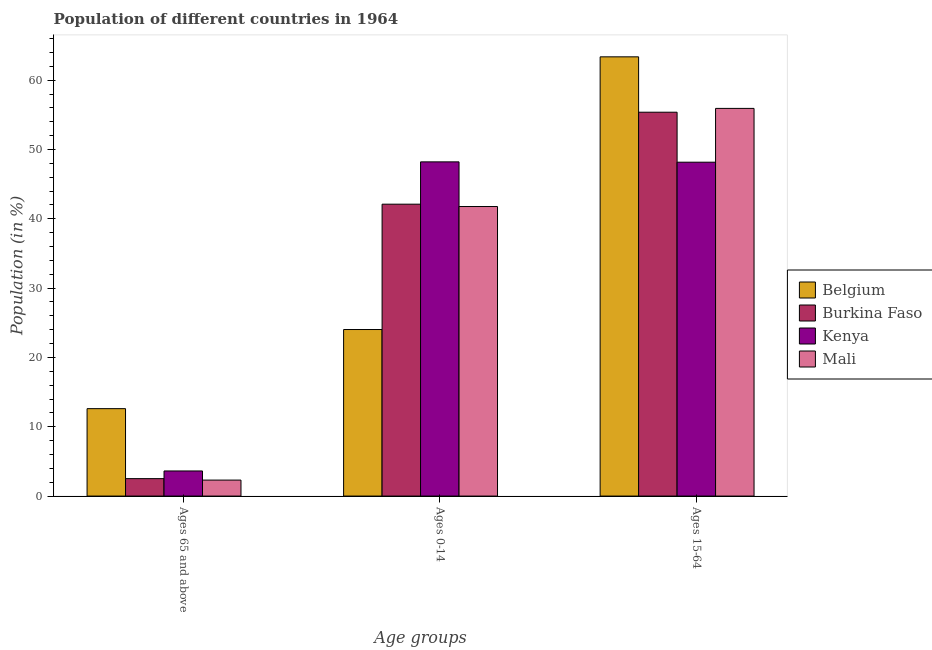How many different coloured bars are there?
Give a very brief answer. 4. Are the number of bars per tick equal to the number of legend labels?
Your answer should be very brief. Yes. How many bars are there on the 3rd tick from the left?
Offer a very short reply. 4. What is the label of the 2nd group of bars from the left?
Provide a short and direct response. Ages 0-14. What is the percentage of population within the age-group of 65 and above in Burkina Faso?
Your response must be concise. 2.52. Across all countries, what is the maximum percentage of population within the age-group 0-14?
Your answer should be compact. 48.21. Across all countries, what is the minimum percentage of population within the age-group 15-64?
Offer a very short reply. 48.17. In which country was the percentage of population within the age-group of 65 and above maximum?
Keep it short and to the point. Belgium. What is the total percentage of population within the age-group of 65 and above in the graph?
Your response must be concise. 21.05. What is the difference between the percentage of population within the age-group 0-14 in Belgium and that in Kenya?
Offer a very short reply. -24.19. What is the difference between the percentage of population within the age-group 15-64 in Burkina Faso and the percentage of population within the age-group of 65 and above in Belgium?
Provide a short and direct response. 42.76. What is the average percentage of population within the age-group 15-64 per country?
Your answer should be compact. 55.71. What is the difference between the percentage of population within the age-group 0-14 and percentage of population within the age-group of 65 and above in Mali?
Ensure brevity in your answer.  39.47. In how many countries, is the percentage of population within the age-group 0-14 greater than 54 %?
Offer a very short reply. 0. What is the ratio of the percentage of population within the age-group 0-14 in Burkina Faso to that in Belgium?
Your response must be concise. 1.75. Is the percentage of population within the age-group of 65 and above in Burkina Faso less than that in Mali?
Offer a terse response. No. What is the difference between the highest and the second highest percentage of population within the age-group 0-14?
Your answer should be very brief. 6.1. What is the difference between the highest and the lowest percentage of population within the age-group 0-14?
Your answer should be compact. 24.19. What does the 3rd bar from the left in Ages 15-64 represents?
Your response must be concise. Kenya. What does the 4th bar from the right in Ages 0-14 represents?
Give a very brief answer. Belgium. How many bars are there?
Your answer should be very brief. 12. Are all the bars in the graph horizontal?
Offer a terse response. No. How many countries are there in the graph?
Give a very brief answer. 4. Are the values on the major ticks of Y-axis written in scientific E-notation?
Your answer should be very brief. No. How many legend labels are there?
Your answer should be compact. 4. How are the legend labels stacked?
Keep it short and to the point. Vertical. What is the title of the graph?
Make the answer very short. Population of different countries in 1964. Does "Senegal" appear as one of the legend labels in the graph?
Provide a succinct answer. No. What is the label or title of the X-axis?
Give a very brief answer. Age groups. What is the Population (in %) of Belgium in Ages 65 and above?
Offer a very short reply. 12.61. What is the Population (in %) in Burkina Faso in Ages 65 and above?
Your answer should be very brief. 2.52. What is the Population (in %) of Kenya in Ages 65 and above?
Your answer should be very brief. 3.62. What is the Population (in %) in Mali in Ages 65 and above?
Provide a succinct answer. 2.3. What is the Population (in %) of Belgium in Ages 0-14?
Keep it short and to the point. 24.02. What is the Population (in %) in Burkina Faso in Ages 0-14?
Offer a terse response. 42.11. What is the Population (in %) of Kenya in Ages 0-14?
Offer a terse response. 48.21. What is the Population (in %) of Mali in Ages 0-14?
Your response must be concise. 41.77. What is the Population (in %) in Belgium in Ages 15-64?
Give a very brief answer. 63.36. What is the Population (in %) of Burkina Faso in Ages 15-64?
Offer a terse response. 55.38. What is the Population (in %) of Kenya in Ages 15-64?
Make the answer very short. 48.17. What is the Population (in %) in Mali in Ages 15-64?
Your answer should be compact. 55.93. Across all Age groups, what is the maximum Population (in %) in Belgium?
Ensure brevity in your answer.  63.36. Across all Age groups, what is the maximum Population (in %) in Burkina Faso?
Provide a succinct answer. 55.38. Across all Age groups, what is the maximum Population (in %) of Kenya?
Keep it short and to the point. 48.21. Across all Age groups, what is the maximum Population (in %) of Mali?
Make the answer very short. 55.93. Across all Age groups, what is the minimum Population (in %) in Belgium?
Your answer should be compact. 12.61. Across all Age groups, what is the minimum Population (in %) of Burkina Faso?
Your answer should be compact. 2.52. Across all Age groups, what is the minimum Population (in %) in Kenya?
Your answer should be very brief. 3.62. Across all Age groups, what is the minimum Population (in %) in Mali?
Provide a succinct answer. 2.3. What is the total Population (in %) of Belgium in the graph?
Make the answer very short. 100. What is the total Population (in %) of Burkina Faso in the graph?
Give a very brief answer. 100. What is the total Population (in %) in Kenya in the graph?
Give a very brief answer. 100. What is the difference between the Population (in %) of Belgium in Ages 65 and above and that in Ages 0-14?
Offer a terse response. -11.41. What is the difference between the Population (in %) in Burkina Faso in Ages 65 and above and that in Ages 0-14?
Offer a terse response. -39.59. What is the difference between the Population (in %) in Kenya in Ages 65 and above and that in Ages 0-14?
Provide a succinct answer. -44.59. What is the difference between the Population (in %) in Mali in Ages 65 and above and that in Ages 0-14?
Your answer should be compact. -39.47. What is the difference between the Population (in %) in Belgium in Ages 65 and above and that in Ages 15-64?
Offer a terse response. -50.75. What is the difference between the Population (in %) in Burkina Faso in Ages 65 and above and that in Ages 15-64?
Keep it short and to the point. -52.86. What is the difference between the Population (in %) in Kenya in Ages 65 and above and that in Ages 15-64?
Offer a very short reply. -44.54. What is the difference between the Population (in %) in Mali in Ages 65 and above and that in Ages 15-64?
Make the answer very short. -53.62. What is the difference between the Population (in %) of Belgium in Ages 0-14 and that in Ages 15-64?
Offer a very short reply. -39.34. What is the difference between the Population (in %) in Burkina Faso in Ages 0-14 and that in Ages 15-64?
Offer a very short reply. -13.27. What is the difference between the Population (in %) in Kenya in Ages 0-14 and that in Ages 15-64?
Provide a short and direct response. 0.05. What is the difference between the Population (in %) of Mali in Ages 0-14 and that in Ages 15-64?
Your response must be concise. -14.16. What is the difference between the Population (in %) in Belgium in Ages 65 and above and the Population (in %) in Burkina Faso in Ages 0-14?
Give a very brief answer. -29.5. What is the difference between the Population (in %) in Belgium in Ages 65 and above and the Population (in %) in Kenya in Ages 0-14?
Make the answer very short. -35.6. What is the difference between the Population (in %) of Belgium in Ages 65 and above and the Population (in %) of Mali in Ages 0-14?
Your answer should be very brief. -29.16. What is the difference between the Population (in %) of Burkina Faso in Ages 65 and above and the Population (in %) of Kenya in Ages 0-14?
Give a very brief answer. -45.7. What is the difference between the Population (in %) in Burkina Faso in Ages 65 and above and the Population (in %) in Mali in Ages 0-14?
Offer a terse response. -39.25. What is the difference between the Population (in %) of Kenya in Ages 65 and above and the Population (in %) of Mali in Ages 0-14?
Ensure brevity in your answer.  -38.15. What is the difference between the Population (in %) in Belgium in Ages 65 and above and the Population (in %) in Burkina Faso in Ages 15-64?
Provide a succinct answer. -42.76. What is the difference between the Population (in %) in Belgium in Ages 65 and above and the Population (in %) in Kenya in Ages 15-64?
Provide a short and direct response. -35.55. What is the difference between the Population (in %) in Belgium in Ages 65 and above and the Population (in %) in Mali in Ages 15-64?
Provide a short and direct response. -43.31. What is the difference between the Population (in %) in Burkina Faso in Ages 65 and above and the Population (in %) in Kenya in Ages 15-64?
Your response must be concise. -45.65. What is the difference between the Population (in %) in Burkina Faso in Ages 65 and above and the Population (in %) in Mali in Ages 15-64?
Provide a succinct answer. -53.41. What is the difference between the Population (in %) of Kenya in Ages 65 and above and the Population (in %) of Mali in Ages 15-64?
Offer a very short reply. -52.3. What is the difference between the Population (in %) of Belgium in Ages 0-14 and the Population (in %) of Burkina Faso in Ages 15-64?
Your response must be concise. -31.35. What is the difference between the Population (in %) of Belgium in Ages 0-14 and the Population (in %) of Kenya in Ages 15-64?
Your answer should be very brief. -24.14. What is the difference between the Population (in %) in Belgium in Ages 0-14 and the Population (in %) in Mali in Ages 15-64?
Your answer should be very brief. -31.9. What is the difference between the Population (in %) in Burkina Faso in Ages 0-14 and the Population (in %) in Kenya in Ages 15-64?
Offer a very short reply. -6.06. What is the difference between the Population (in %) in Burkina Faso in Ages 0-14 and the Population (in %) in Mali in Ages 15-64?
Your answer should be very brief. -13.82. What is the difference between the Population (in %) in Kenya in Ages 0-14 and the Population (in %) in Mali in Ages 15-64?
Ensure brevity in your answer.  -7.71. What is the average Population (in %) in Belgium per Age groups?
Provide a succinct answer. 33.33. What is the average Population (in %) in Burkina Faso per Age groups?
Offer a terse response. 33.33. What is the average Population (in %) in Kenya per Age groups?
Offer a very short reply. 33.33. What is the average Population (in %) in Mali per Age groups?
Keep it short and to the point. 33.33. What is the difference between the Population (in %) of Belgium and Population (in %) of Burkina Faso in Ages 65 and above?
Provide a succinct answer. 10.1. What is the difference between the Population (in %) of Belgium and Population (in %) of Kenya in Ages 65 and above?
Offer a very short reply. 8.99. What is the difference between the Population (in %) of Belgium and Population (in %) of Mali in Ages 65 and above?
Provide a succinct answer. 10.31. What is the difference between the Population (in %) of Burkina Faso and Population (in %) of Kenya in Ages 65 and above?
Offer a terse response. -1.11. What is the difference between the Population (in %) in Burkina Faso and Population (in %) in Mali in Ages 65 and above?
Your response must be concise. 0.21. What is the difference between the Population (in %) in Kenya and Population (in %) in Mali in Ages 65 and above?
Offer a very short reply. 1.32. What is the difference between the Population (in %) in Belgium and Population (in %) in Burkina Faso in Ages 0-14?
Offer a terse response. -18.08. What is the difference between the Population (in %) of Belgium and Population (in %) of Kenya in Ages 0-14?
Your response must be concise. -24.19. What is the difference between the Population (in %) of Belgium and Population (in %) of Mali in Ages 0-14?
Make the answer very short. -17.74. What is the difference between the Population (in %) of Burkina Faso and Population (in %) of Kenya in Ages 0-14?
Ensure brevity in your answer.  -6.1. What is the difference between the Population (in %) of Burkina Faso and Population (in %) of Mali in Ages 0-14?
Make the answer very short. 0.34. What is the difference between the Population (in %) in Kenya and Population (in %) in Mali in Ages 0-14?
Your response must be concise. 6.44. What is the difference between the Population (in %) in Belgium and Population (in %) in Burkina Faso in Ages 15-64?
Provide a short and direct response. 7.99. What is the difference between the Population (in %) of Belgium and Population (in %) of Kenya in Ages 15-64?
Offer a terse response. 15.2. What is the difference between the Population (in %) of Belgium and Population (in %) of Mali in Ages 15-64?
Make the answer very short. 7.44. What is the difference between the Population (in %) in Burkina Faso and Population (in %) in Kenya in Ages 15-64?
Provide a short and direct response. 7.21. What is the difference between the Population (in %) in Burkina Faso and Population (in %) in Mali in Ages 15-64?
Offer a terse response. -0.55. What is the difference between the Population (in %) in Kenya and Population (in %) in Mali in Ages 15-64?
Provide a short and direct response. -7.76. What is the ratio of the Population (in %) in Belgium in Ages 65 and above to that in Ages 0-14?
Your answer should be compact. 0.52. What is the ratio of the Population (in %) in Burkina Faso in Ages 65 and above to that in Ages 0-14?
Offer a very short reply. 0.06. What is the ratio of the Population (in %) in Kenya in Ages 65 and above to that in Ages 0-14?
Offer a very short reply. 0.08. What is the ratio of the Population (in %) of Mali in Ages 65 and above to that in Ages 0-14?
Make the answer very short. 0.06. What is the ratio of the Population (in %) of Belgium in Ages 65 and above to that in Ages 15-64?
Offer a very short reply. 0.2. What is the ratio of the Population (in %) of Burkina Faso in Ages 65 and above to that in Ages 15-64?
Offer a terse response. 0.05. What is the ratio of the Population (in %) of Kenya in Ages 65 and above to that in Ages 15-64?
Your answer should be very brief. 0.08. What is the ratio of the Population (in %) in Mali in Ages 65 and above to that in Ages 15-64?
Give a very brief answer. 0.04. What is the ratio of the Population (in %) in Belgium in Ages 0-14 to that in Ages 15-64?
Offer a terse response. 0.38. What is the ratio of the Population (in %) in Burkina Faso in Ages 0-14 to that in Ages 15-64?
Your response must be concise. 0.76. What is the ratio of the Population (in %) of Mali in Ages 0-14 to that in Ages 15-64?
Your answer should be compact. 0.75. What is the difference between the highest and the second highest Population (in %) in Belgium?
Your answer should be very brief. 39.34. What is the difference between the highest and the second highest Population (in %) in Burkina Faso?
Your answer should be compact. 13.27. What is the difference between the highest and the second highest Population (in %) in Kenya?
Keep it short and to the point. 0.05. What is the difference between the highest and the second highest Population (in %) in Mali?
Make the answer very short. 14.16. What is the difference between the highest and the lowest Population (in %) in Belgium?
Your response must be concise. 50.75. What is the difference between the highest and the lowest Population (in %) in Burkina Faso?
Offer a very short reply. 52.86. What is the difference between the highest and the lowest Population (in %) of Kenya?
Ensure brevity in your answer.  44.59. What is the difference between the highest and the lowest Population (in %) in Mali?
Offer a very short reply. 53.62. 